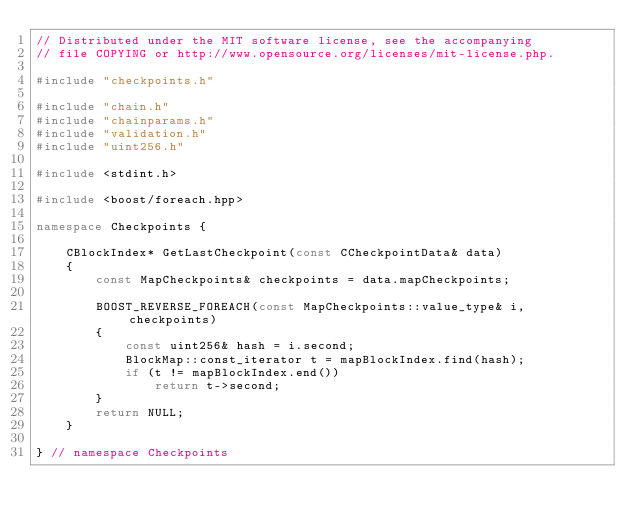<code> <loc_0><loc_0><loc_500><loc_500><_C++_>// Distributed under the MIT software license, see the accompanying
// file COPYING or http://www.opensource.org/licenses/mit-license.php.

#include "checkpoints.h"

#include "chain.h"
#include "chainparams.h"
#include "validation.h"
#include "uint256.h"

#include <stdint.h>

#include <boost/foreach.hpp>

namespace Checkpoints {

    CBlockIndex* GetLastCheckpoint(const CCheckpointData& data)
    {
        const MapCheckpoints& checkpoints = data.mapCheckpoints;

        BOOST_REVERSE_FOREACH(const MapCheckpoints::value_type& i, checkpoints)
        {
            const uint256& hash = i.second;
            BlockMap::const_iterator t = mapBlockIndex.find(hash);
            if (t != mapBlockIndex.end())
                return t->second;
        }
        return NULL;
    }

} // namespace Checkpoints
</code> 